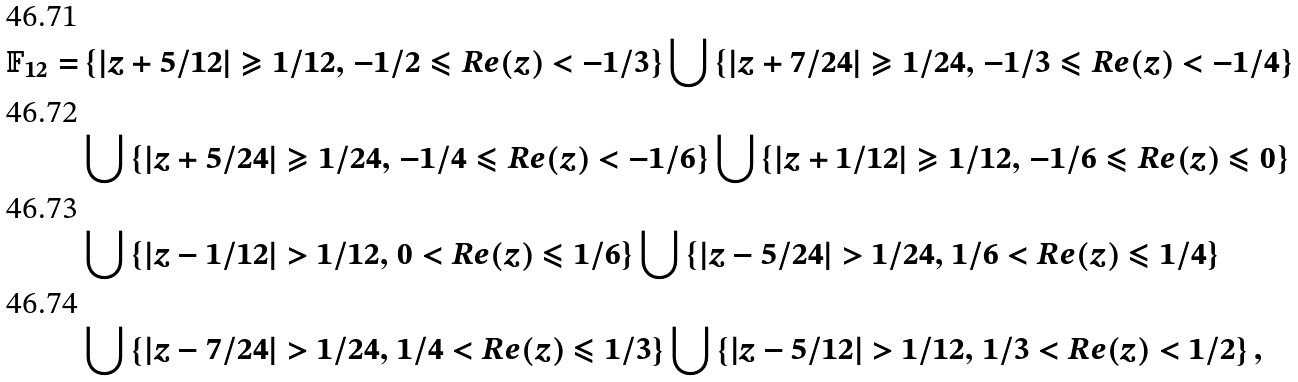<formula> <loc_0><loc_0><loc_500><loc_500>\mathbb { F } _ { 1 2 } = & \left \{ | z + 5 / 1 2 | \geqslant 1 / 1 2 , \, - 1 / 2 \leqslant R e ( z ) < - 1 / 3 \right \} \bigcup \left \{ | z + 7 / 2 4 | \geqslant 1 / 2 4 , \, - 1 / 3 \leqslant R e ( z ) < - 1 / 4 \right \} \\ & \bigcup \left \{ | z + 5 / 2 4 | \geqslant 1 / 2 4 , \, - 1 / 4 \leqslant R e ( z ) < - 1 / 6 \right \} \bigcup \left \{ | z + 1 / 1 2 | \geqslant 1 / 1 2 , \, - 1 / 6 \leqslant R e ( z ) \leqslant 0 \right \} \\ & \bigcup \left \{ | z - 1 / 1 2 | > 1 / 1 2 , \, 0 < R e ( z ) \leqslant 1 / 6 \right \} \bigcup \left \{ | z - 5 / 2 4 | > 1 / 2 4 , \, 1 / 6 < R e ( z ) \leqslant 1 / 4 \right \} \\ & \bigcup \left \{ | z - 7 / 2 4 | > 1 / 2 4 , \, 1 / 4 < R e ( z ) \leqslant 1 / 3 \right \} \bigcup \left \{ | z - 5 / 1 2 | > 1 / 1 2 , \, 1 / 3 < R e ( z ) < 1 / 2 \right \} ,</formula> 